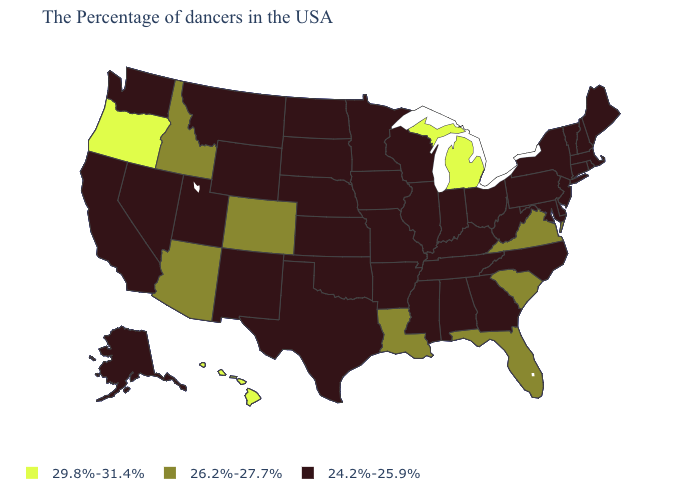What is the value of Nebraska?
Quick response, please. 24.2%-25.9%. What is the lowest value in the USA?
Quick response, please. 24.2%-25.9%. Name the states that have a value in the range 26.2%-27.7%?
Answer briefly. Virginia, South Carolina, Florida, Louisiana, Colorado, Arizona, Idaho. Does California have the same value as New Jersey?
Write a very short answer. Yes. What is the value of Washington?
Keep it brief. 24.2%-25.9%. Does Wisconsin have the same value as Georgia?
Quick response, please. Yes. Does Michigan have the highest value in the USA?
Give a very brief answer. Yes. What is the value of Minnesota?
Keep it brief. 24.2%-25.9%. What is the value of Maryland?
Keep it brief. 24.2%-25.9%. Is the legend a continuous bar?
Concise answer only. No. Which states hav the highest value in the MidWest?
Write a very short answer. Michigan. Among the states that border Minnesota , which have the lowest value?
Short answer required. Wisconsin, Iowa, South Dakota, North Dakota. Name the states that have a value in the range 24.2%-25.9%?
Write a very short answer. Maine, Massachusetts, Rhode Island, New Hampshire, Vermont, Connecticut, New York, New Jersey, Delaware, Maryland, Pennsylvania, North Carolina, West Virginia, Ohio, Georgia, Kentucky, Indiana, Alabama, Tennessee, Wisconsin, Illinois, Mississippi, Missouri, Arkansas, Minnesota, Iowa, Kansas, Nebraska, Oklahoma, Texas, South Dakota, North Dakota, Wyoming, New Mexico, Utah, Montana, Nevada, California, Washington, Alaska. Is the legend a continuous bar?
Concise answer only. No. Does the map have missing data?
Be succinct. No. 